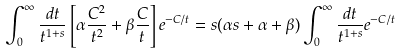Convert formula to latex. <formula><loc_0><loc_0><loc_500><loc_500>\int _ { 0 } ^ { \infty } \frac { d t } { t ^ { 1 + s } } \left [ \alpha \frac { C ^ { 2 } } { t ^ { 2 } } + \beta \frac { C } { t } \right ] e ^ { - C / t } = s ( \alpha s + \alpha + \beta ) \int _ { 0 } ^ { \infty } \frac { d t } { t ^ { 1 + s } } e ^ { - C / t }</formula> 